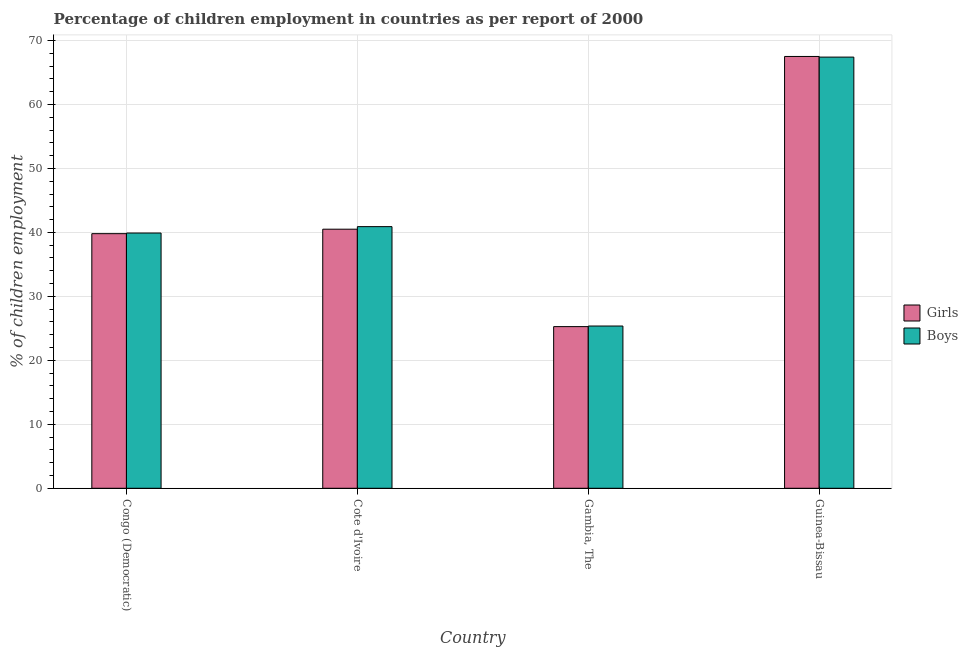How many bars are there on the 1st tick from the left?
Ensure brevity in your answer.  2. What is the label of the 2nd group of bars from the left?
Your answer should be very brief. Cote d'Ivoire. What is the percentage of employed boys in Gambia, The?
Your answer should be compact. 25.36. Across all countries, what is the maximum percentage of employed girls?
Give a very brief answer. 67.5. Across all countries, what is the minimum percentage of employed girls?
Your answer should be very brief. 25.27. In which country was the percentage of employed girls maximum?
Your response must be concise. Guinea-Bissau. In which country was the percentage of employed boys minimum?
Ensure brevity in your answer.  Gambia, The. What is the total percentage of employed boys in the graph?
Offer a very short reply. 173.56. What is the difference between the percentage of employed boys in Cote d'Ivoire and that in Gambia, The?
Give a very brief answer. 15.54. What is the difference between the percentage of employed boys in Guinea-Bissau and the percentage of employed girls in Cote d'Ivoire?
Make the answer very short. 26.9. What is the average percentage of employed girls per country?
Your answer should be very brief. 43.27. What is the difference between the percentage of employed girls and percentage of employed boys in Cote d'Ivoire?
Ensure brevity in your answer.  -0.4. In how many countries, is the percentage of employed boys greater than 22 %?
Offer a terse response. 4. What is the ratio of the percentage of employed boys in Gambia, The to that in Guinea-Bissau?
Your answer should be compact. 0.38. Is the difference between the percentage of employed boys in Congo (Democratic) and Guinea-Bissau greater than the difference between the percentage of employed girls in Congo (Democratic) and Guinea-Bissau?
Your response must be concise. Yes. What is the difference between the highest and the lowest percentage of employed boys?
Your answer should be compact. 42.04. In how many countries, is the percentage of employed girls greater than the average percentage of employed girls taken over all countries?
Your answer should be compact. 1. What does the 2nd bar from the left in Gambia, The represents?
Make the answer very short. Boys. What does the 1st bar from the right in Cote d'Ivoire represents?
Give a very brief answer. Boys. How many bars are there?
Your response must be concise. 8. Are all the bars in the graph horizontal?
Your answer should be very brief. No. How many countries are there in the graph?
Give a very brief answer. 4. Does the graph contain grids?
Keep it short and to the point. Yes. Where does the legend appear in the graph?
Give a very brief answer. Center right. How are the legend labels stacked?
Your answer should be compact. Vertical. What is the title of the graph?
Ensure brevity in your answer.  Percentage of children employment in countries as per report of 2000. Does "Register a business" appear as one of the legend labels in the graph?
Keep it short and to the point. No. What is the label or title of the X-axis?
Make the answer very short. Country. What is the label or title of the Y-axis?
Offer a terse response. % of children employment. What is the % of children employment in Girls in Congo (Democratic)?
Ensure brevity in your answer.  39.8. What is the % of children employment of Boys in Congo (Democratic)?
Provide a succinct answer. 39.9. What is the % of children employment in Girls in Cote d'Ivoire?
Provide a short and direct response. 40.5. What is the % of children employment of Boys in Cote d'Ivoire?
Offer a terse response. 40.9. What is the % of children employment in Girls in Gambia, The?
Give a very brief answer. 25.27. What is the % of children employment of Boys in Gambia, The?
Your response must be concise. 25.36. What is the % of children employment of Girls in Guinea-Bissau?
Give a very brief answer. 67.5. What is the % of children employment in Boys in Guinea-Bissau?
Offer a terse response. 67.4. Across all countries, what is the maximum % of children employment of Girls?
Offer a terse response. 67.5. Across all countries, what is the maximum % of children employment of Boys?
Offer a very short reply. 67.4. Across all countries, what is the minimum % of children employment of Girls?
Make the answer very short. 25.27. Across all countries, what is the minimum % of children employment of Boys?
Your answer should be compact. 25.36. What is the total % of children employment of Girls in the graph?
Ensure brevity in your answer.  173.07. What is the total % of children employment of Boys in the graph?
Make the answer very short. 173.56. What is the difference between the % of children employment in Girls in Congo (Democratic) and that in Gambia, The?
Ensure brevity in your answer.  14.53. What is the difference between the % of children employment of Boys in Congo (Democratic) and that in Gambia, The?
Give a very brief answer. 14.54. What is the difference between the % of children employment in Girls in Congo (Democratic) and that in Guinea-Bissau?
Make the answer very short. -27.7. What is the difference between the % of children employment of Boys in Congo (Democratic) and that in Guinea-Bissau?
Offer a terse response. -27.5. What is the difference between the % of children employment of Girls in Cote d'Ivoire and that in Gambia, The?
Make the answer very short. 15.23. What is the difference between the % of children employment in Boys in Cote d'Ivoire and that in Gambia, The?
Ensure brevity in your answer.  15.54. What is the difference between the % of children employment in Boys in Cote d'Ivoire and that in Guinea-Bissau?
Your answer should be very brief. -26.5. What is the difference between the % of children employment of Girls in Gambia, The and that in Guinea-Bissau?
Provide a short and direct response. -42.23. What is the difference between the % of children employment of Boys in Gambia, The and that in Guinea-Bissau?
Make the answer very short. -42.04. What is the difference between the % of children employment in Girls in Congo (Democratic) and the % of children employment in Boys in Gambia, The?
Provide a short and direct response. 14.44. What is the difference between the % of children employment in Girls in Congo (Democratic) and the % of children employment in Boys in Guinea-Bissau?
Provide a short and direct response. -27.6. What is the difference between the % of children employment of Girls in Cote d'Ivoire and the % of children employment of Boys in Gambia, The?
Ensure brevity in your answer.  15.14. What is the difference between the % of children employment of Girls in Cote d'Ivoire and the % of children employment of Boys in Guinea-Bissau?
Ensure brevity in your answer.  -26.9. What is the difference between the % of children employment in Girls in Gambia, The and the % of children employment in Boys in Guinea-Bissau?
Make the answer very short. -42.13. What is the average % of children employment of Girls per country?
Ensure brevity in your answer.  43.27. What is the average % of children employment of Boys per country?
Offer a terse response. 43.39. What is the difference between the % of children employment in Girls and % of children employment in Boys in Congo (Democratic)?
Your answer should be compact. -0.1. What is the difference between the % of children employment in Girls and % of children employment in Boys in Cote d'Ivoire?
Make the answer very short. -0.4. What is the difference between the % of children employment in Girls and % of children employment in Boys in Gambia, The?
Keep it short and to the point. -0.09. What is the ratio of the % of children employment of Girls in Congo (Democratic) to that in Cote d'Ivoire?
Keep it short and to the point. 0.98. What is the ratio of the % of children employment of Boys in Congo (Democratic) to that in Cote d'Ivoire?
Make the answer very short. 0.98. What is the ratio of the % of children employment of Girls in Congo (Democratic) to that in Gambia, The?
Give a very brief answer. 1.57. What is the ratio of the % of children employment in Boys in Congo (Democratic) to that in Gambia, The?
Ensure brevity in your answer.  1.57. What is the ratio of the % of children employment of Girls in Congo (Democratic) to that in Guinea-Bissau?
Provide a succinct answer. 0.59. What is the ratio of the % of children employment of Boys in Congo (Democratic) to that in Guinea-Bissau?
Make the answer very short. 0.59. What is the ratio of the % of children employment of Girls in Cote d'Ivoire to that in Gambia, The?
Keep it short and to the point. 1.6. What is the ratio of the % of children employment of Boys in Cote d'Ivoire to that in Gambia, The?
Your answer should be compact. 1.61. What is the ratio of the % of children employment of Boys in Cote d'Ivoire to that in Guinea-Bissau?
Offer a very short reply. 0.61. What is the ratio of the % of children employment of Girls in Gambia, The to that in Guinea-Bissau?
Offer a terse response. 0.37. What is the ratio of the % of children employment of Boys in Gambia, The to that in Guinea-Bissau?
Give a very brief answer. 0.38. What is the difference between the highest and the second highest % of children employment of Girls?
Keep it short and to the point. 27. What is the difference between the highest and the lowest % of children employment in Girls?
Make the answer very short. 42.23. What is the difference between the highest and the lowest % of children employment in Boys?
Keep it short and to the point. 42.04. 